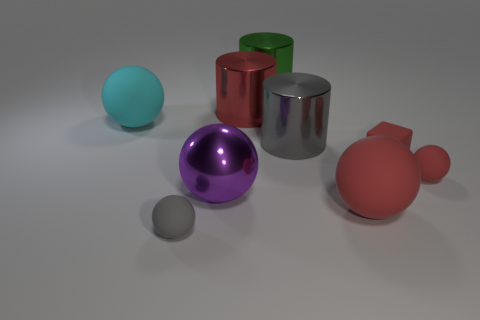How many red balls must be subtracted to get 1 red balls? 1 Subtract all gray spheres. How many spheres are left? 4 Subtract all big purple spheres. How many spheres are left? 4 Subtract all purple spheres. Subtract all yellow cylinders. How many spheres are left? 4 Add 1 tiny blue matte blocks. How many objects exist? 10 Subtract all blocks. How many objects are left? 8 Add 7 large purple balls. How many large purple balls are left? 8 Add 9 large red metallic objects. How many large red metallic objects exist? 10 Subtract 1 green cylinders. How many objects are left? 8 Subtract all purple shiny balls. Subtract all big cyan matte balls. How many objects are left? 7 